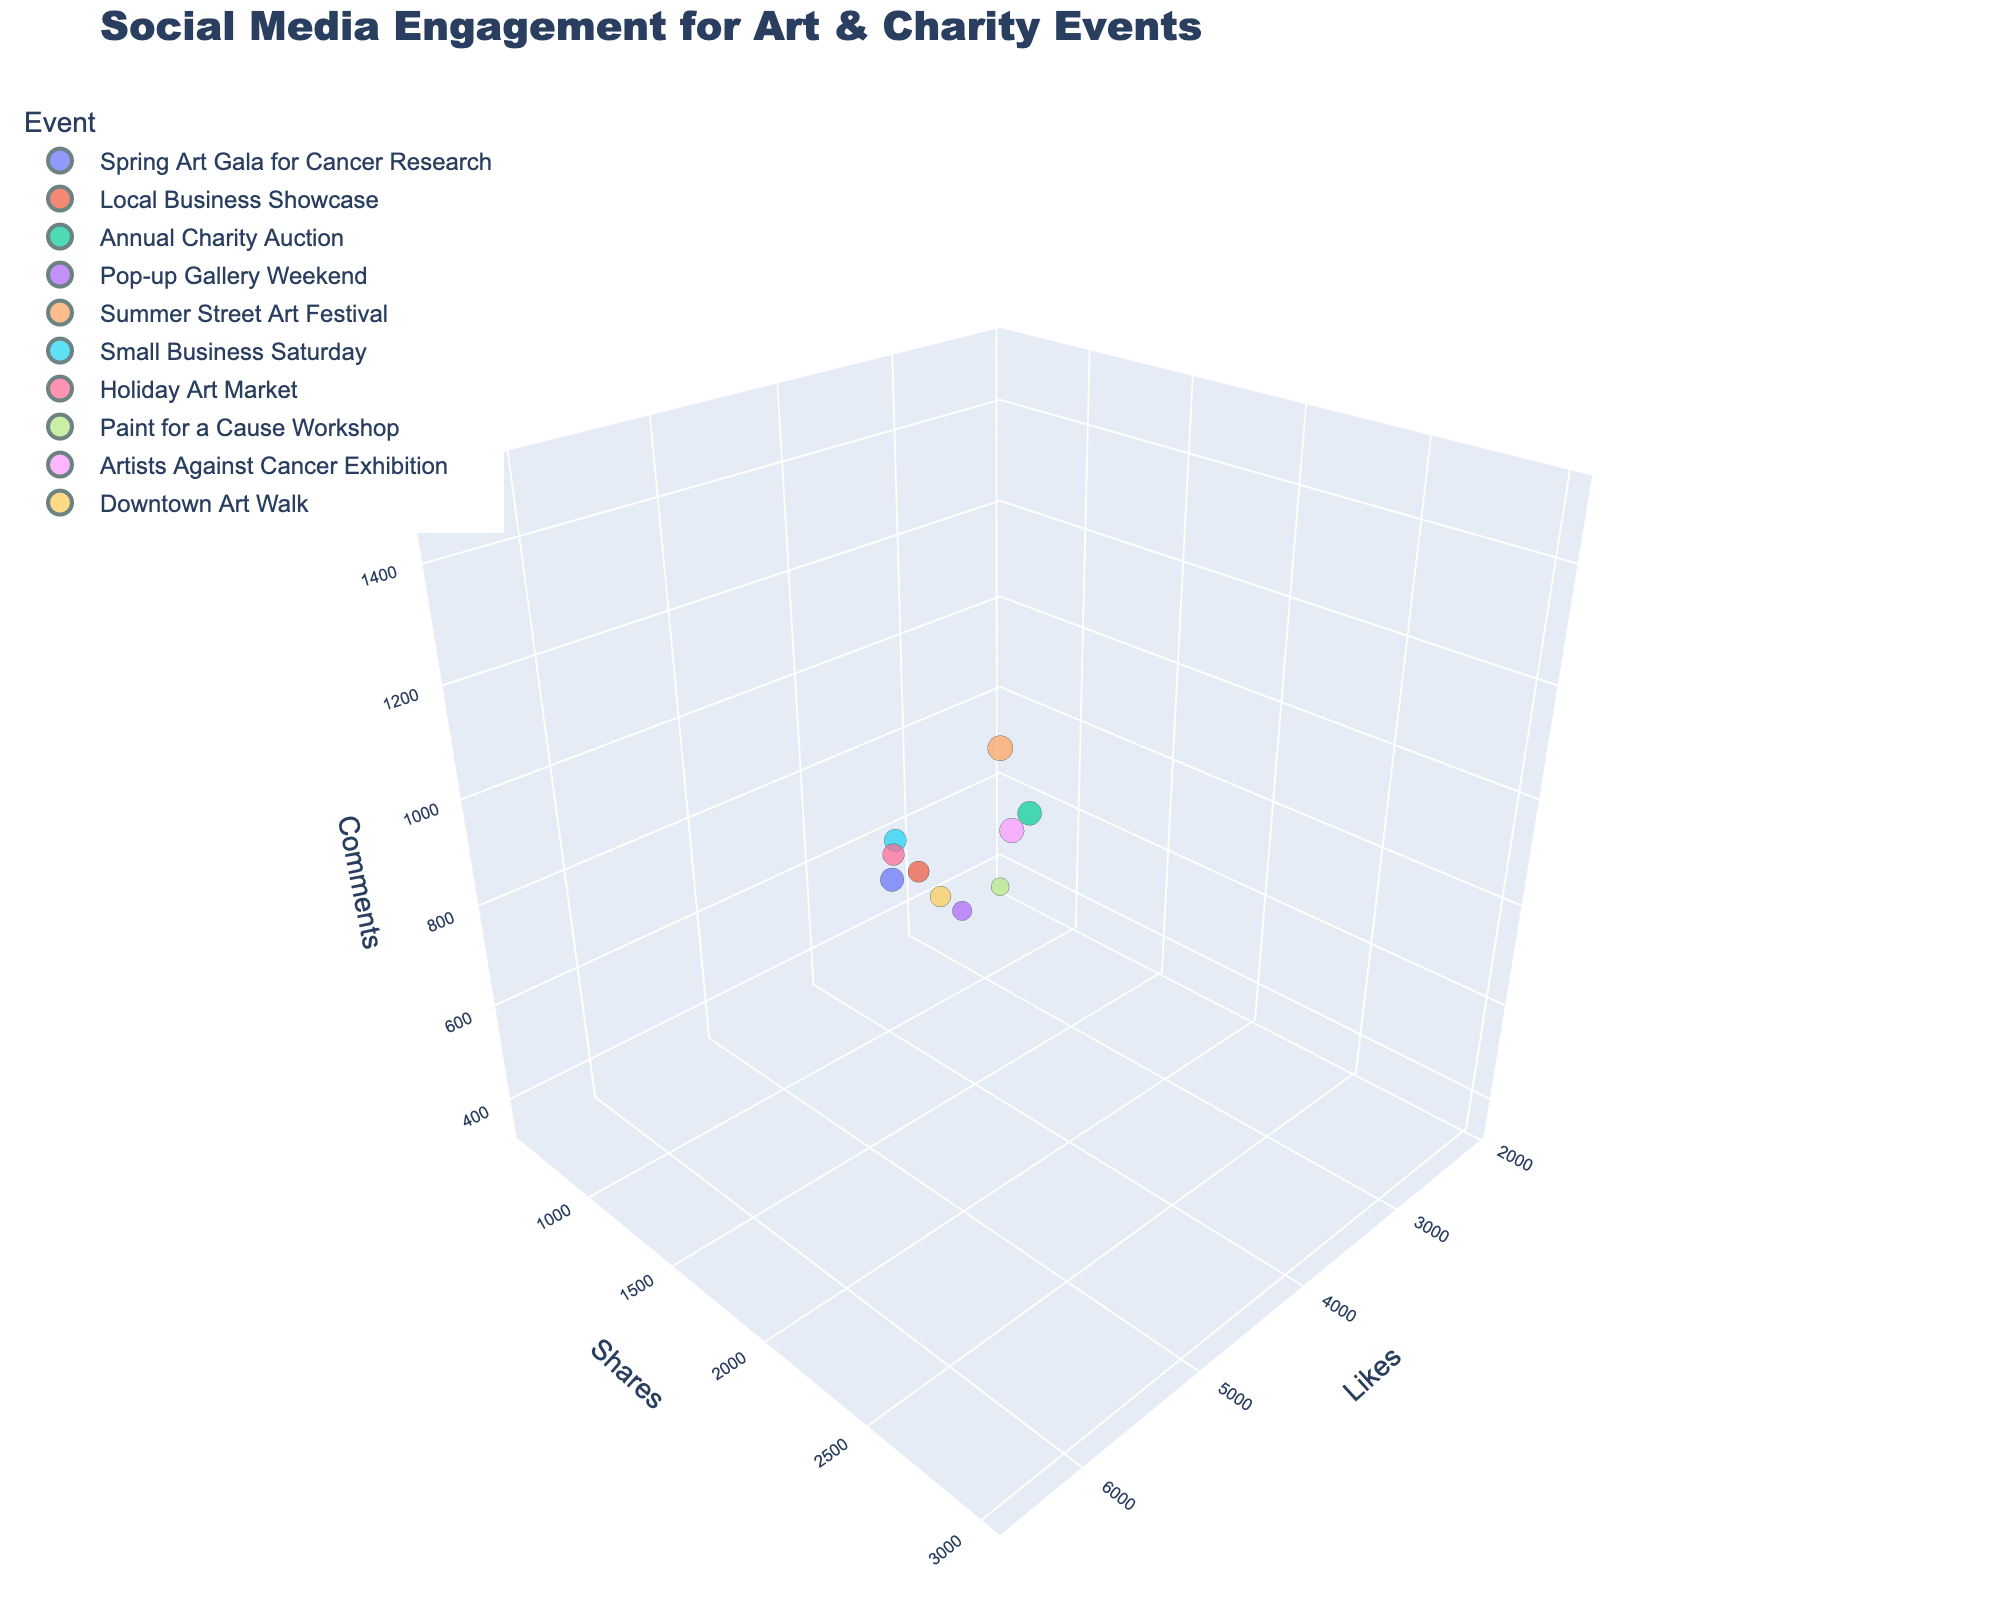What is the title of the figure? The title is usually located at the top of the figure and summarizes the main topic or data being presented. In this case, the title is "Social Media Engagement for Art & Charity Events".
Answer: Social Media Engagement for Art & Charity Events Which event has the highest number of Shares? To identify which event has the highest Shares, look at the y-axis values and compare the bubble positions. The event with the highest y-axis value is "Summer Street Art Festival".
Answer: Summer Street Art Festival Which event has the largest bubble, indicating the highest Reach? The Reach corresponds to the bubble size. The largest bubble on the plot represents the highest Reach, which is for the "Summer Street Art Festival" with a Reach of 100,000.
Answer: Summer Street Art Festival How many events have over 1,000 Comments? To find the number of events with over 1,000 Comments, look at the z-axis values and count the bubbles that exceed the 1,000 mark. There are 4 such events.
Answer: 4 Compare the Likes between the "Spring Art Gala for Cancer Research" and the "Pop-up Gallery Weekend". Which one has more Likes? Locate the events on the x-axis, which represents Likes, and compare their positions. The "Spring Art Gala for Cancer Research" has more Likes (5200) compared to the "Pop-up Gallery Weekend" (2800).
Answer: Spring Art Gala for Cancer Research Which event has the least number of Shares, and how many Shares does it have? Look for the event with the lowest y-axis value. The "Pop-up Gallery Weekend" has the least number of Shares, which is 750.
Answer: Pop-up Gallery Weekend, 750 What is the average number of Comments of the top three events with the highest Likes? Identify the top three events with the highest Likes: "Summer Street Art Festival", "Spring Art Gala for Cancer Research", and "Artists Against Cancer Exhibition". Their Comments are 1500, 950, and 1200 respectively. The average is calculated as (1500 + 950 + 1200) / 3 = 1216.67.
Answer: 1216.67 Which event has higher Shares: "Local Business Showcase" or "Holiday Art Market"? Compare the y-axis values for the "Local Business Showcase" and the "Holiday Art Market". The "Local Business Showcase" has higher Shares (900) compared to the "Holiday Art Market" (1000).
Answer: Holiday Art Market Are there more events with a Reach above 70,000 or below 30,000? Count the number of events with a Reach above 70,000 and those below 30,000. There are 3 events above 70,000 (Spring Art Gala for Cancer Research, Annual Charity Auction, Summer Street Art Festival) and 2 events below 30,000 (Paint for a Cause Workshop, Pop-up Gallery Weekend).
Answer: Above 70,000 Which event lies at the intersection of approximately 2200 Shares and 1100 Comments? Locate the point on the y-axis (Shares) at 2200 and the z-axis (Comments) at 1100. The event at this intersection is "Annual Charity Auction".
Answer: Annual Charity Auction 